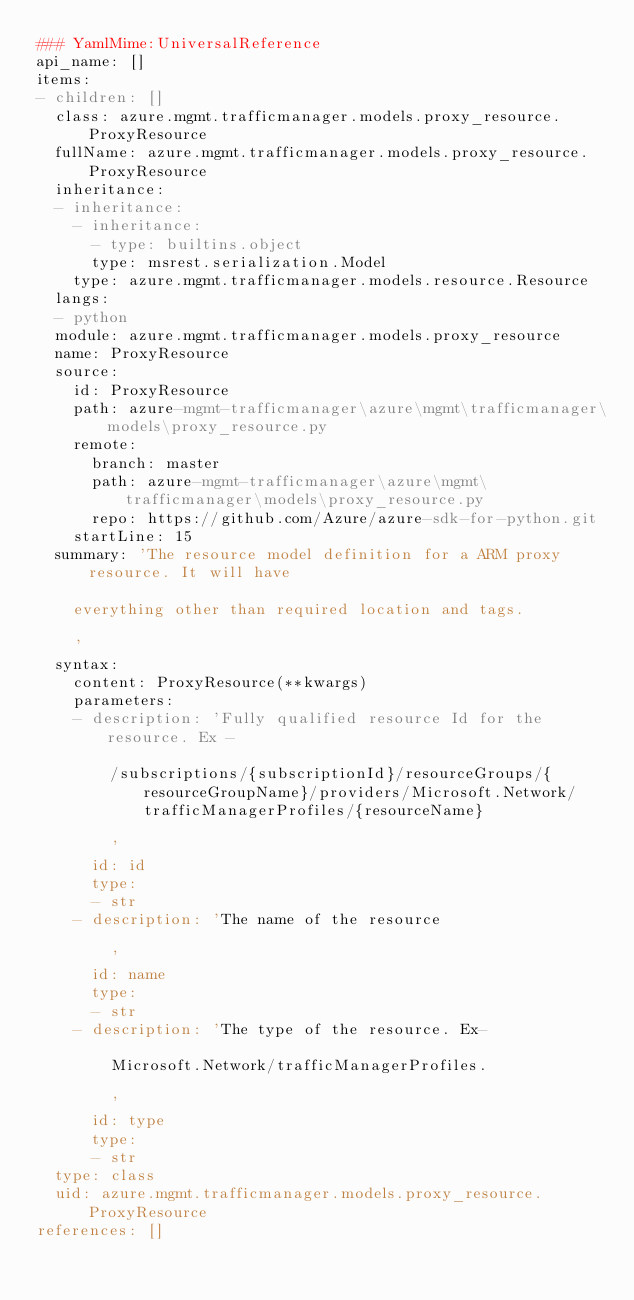Convert code to text. <code><loc_0><loc_0><loc_500><loc_500><_YAML_>### YamlMime:UniversalReference
api_name: []
items:
- children: []
  class: azure.mgmt.trafficmanager.models.proxy_resource.ProxyResource
  fullName: azure.mgmt.trafficmanager.models.proxy_resource.ProxyResource
  inheritance:
  - inheritance:
    - inheritance:
      - type: builtins.object
      type: msrest.serialization.Model
    type: azure.mgmt.trafficmanager.models.resource.Resource
  langs:
  - python
  module: azure.mgmt.trafficmanager.models.proxy_resource
  name: ProxyResource
  source:
    id: ProxyResource
    path: azure-mgmt-trafficmanager\azure\mgmt\trafficmanager\models\proxy_resource.py
    remote:
      branch: master
      path: azure-mgmt-trafficmanager\azure\mgmt\trafficmanager\models\proxy_resource.py
      repo: https://github.com/Azure/azure-sdk-for-python.git
    startLine: 15
  summary: 'The resource model definition for a ARM proxy resource. It will have

    everything other than required location and tags.

    '
  syntax:
    content: ProxyResource(**kwargs)
    parameters:
    - description: 'Fully qualified resource Id for the resource. Ex -

        /subscriptions/{subscriptionId}/resourceGroups/{resourceGroupName}/providers/Microsoft.Network/trafficManagerProfiles/{resourceName}

        '
      id: id
      type:
      - str
    - description: 'The name of the resource

        '
      id: name
      type:
      - str
    - description: 'The type of the resource. Ex-

        Microsoft.Network/trafficManagerProfiles.

        '
      id: type
      type:
      - str
  type: class
  uid: azure.mgmt.trafficmanager.models.proxy_resource.ProxyResource
references: []
</code> 